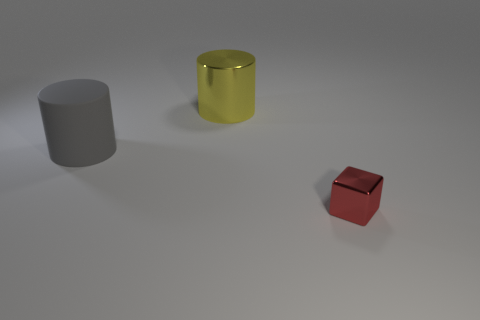There is a red object; is it the same shape as the big thing behind the big matte object?
Provide a short and direct response. No. There is a metal object behind the metallic object in front of the big cylinder behind the rubber thing; what color is it?
Offer a terse response. Yellow. Are there any big rubber cylinders in front of the red thing?
Give a very brief answer. No. Is there a tiny gray cube that has the same material as the big gray thing?
Your response must be concise. No. What color is the small cube?
Your answer should be very brief. Red. Does the thing that is right of the yellow object have the same shape as the big rubber object?
Your response must be concise. No. What is the shape of the large object behind the object that is left of the thing behind the large gray matte cylinder?
Your response must be concise. Cylinder. What is the big cylinder that is in front of the big shiny object made of?
Your answer should be compact. Rubber. What is the color of the rubber thing that is the same size as the yellow shiny object?
Keep it short and to the point. Gray. What number of other objects are the same shape as the gray rubber object?
Your answer should be very brief. 1. 